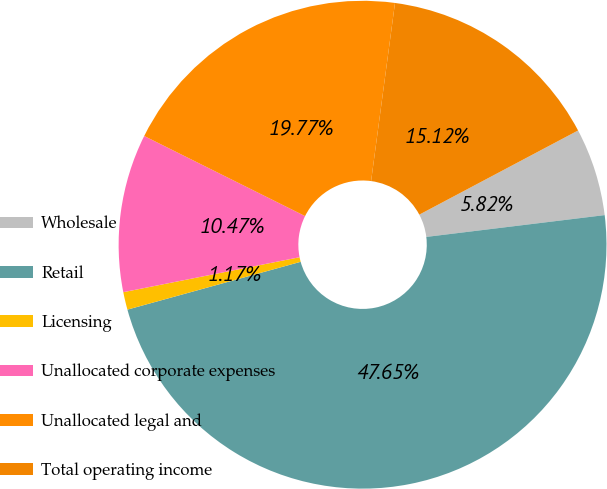Convert chart. <chart><loc_0><loc_0><loc_500><loc_500><pie_chart><fcel>Wholesale<fcel>Retail<fcel>Licensing<fcel>Unallocated corporate expenses<fcel>Unallocated legal and<fcel>Total operating income<nl><fcel>5.82%<fcel>47.65%<fcel>1.17%<fcel>10.47%<fcel>19.77%<fcel>15.12%<nl></chart> 